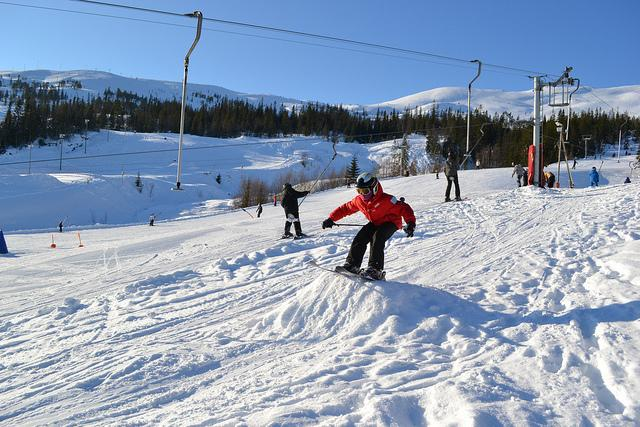After traversing over the jump what natural force will cause the boarder to return to the ground? Please explain your reasoning. gravity. Gravity is something we learn about in grade school. 